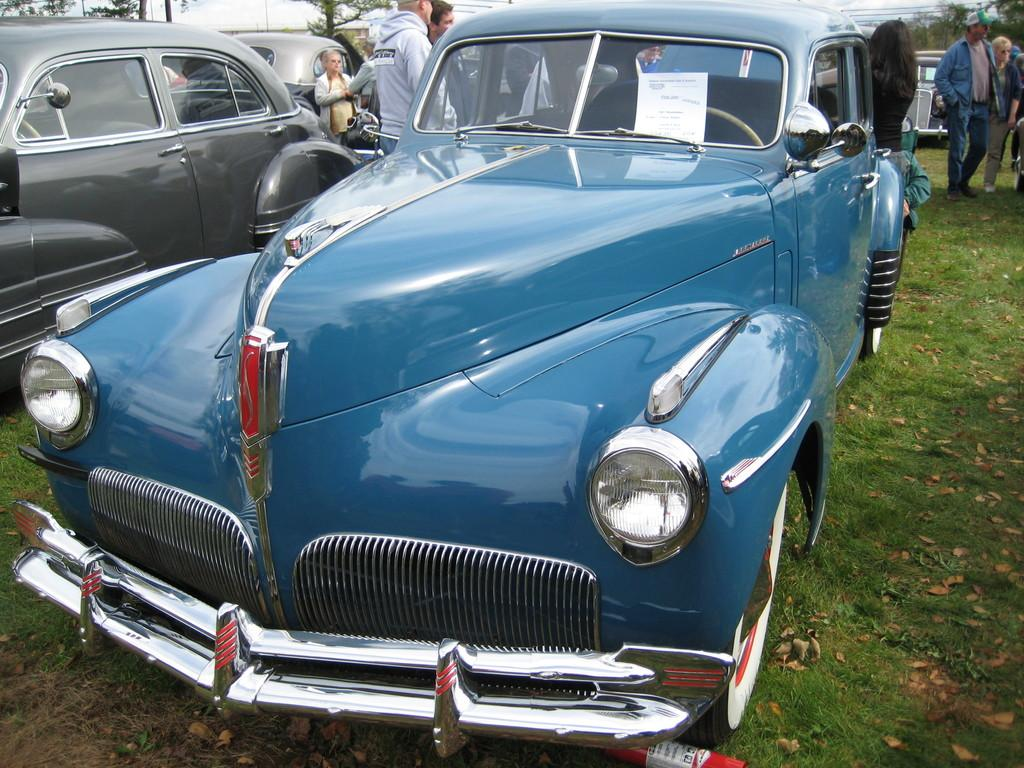What is the main subject in the center of the image? There is a car in the center of the image. Where is the car located? The car is on a grassland. What else can be seen in the background of the image? There are other cars and trees in the background of the image. Are there any people visible in the image? Yes, there are people in the background of the image. What type of fowl can be seen walking down the alley in the image? There is no alley or fowl present in the image. 